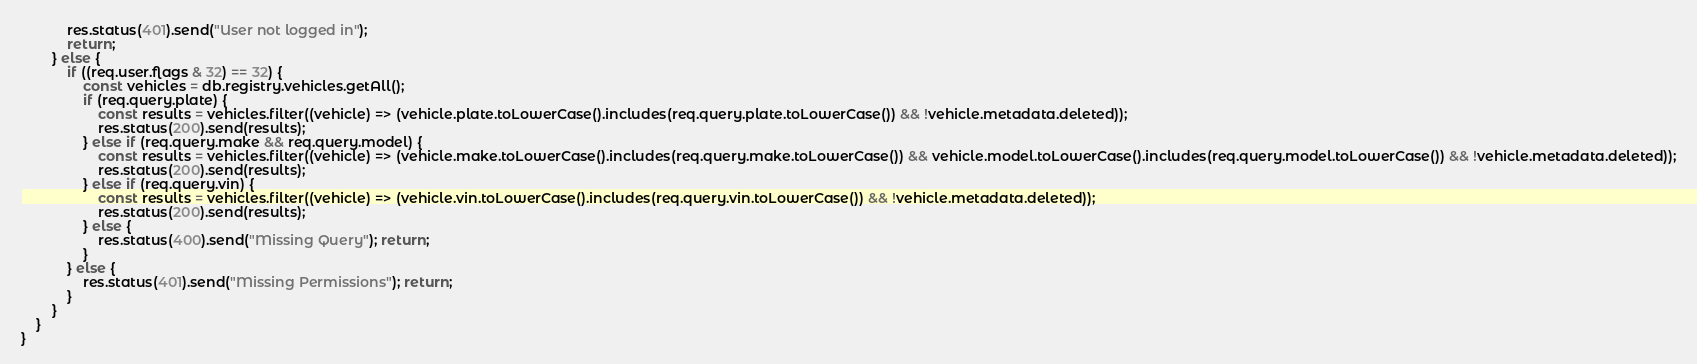<code> <loc_0><loc_0><loc_500><loc_500><_JavaScript_>            res.status(401).send("User not logged in");
            return;
        } else {
            if ((req.user.flags & 32) == 32) {
                const vehicles = db.registry.vehicles.getAll();
                if (req.query.plate) {
                    const results = vehicles.filter((vehicle) => (vehicle.plate.toLowerCase().includes(req.query.plate.toLowerCase()) && !vehicle.metadata.deleted));
                    res.status(200).send(results);
                } else if (req.query.make && req.query.model) {
                    const results = vehicles.filter((vehicle) => (vehicle.make.toLowerCase().includes(req.query.make.toLowerCase()) && vehicle.model.toLowerCase().includes(req.query.model.toLowerCase()) && !vehicle.metadata.deleted));
                    res.status(200).send(results);
                } else if (req.query.vin) {
                    const results = vehicles.filter((vehicle) => (vehicle.vin.toLowerCase().includes(req.query.vin.toLowerCase()) && !vehicle.metadata.deleted));
                    res.status(200).send(results);
                } else {
                    res.status(400).send("Missing Query"); return;
                }
            } else {
                res.status(401).send("Missing Permissions"); return;
            }
        }
    }
}</code> 